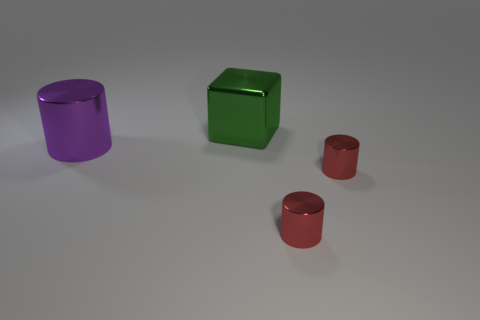Subtract all large purple metallic cylinders. How many cylinders are left? 2 Add 4 big brown rubber objects. How many objects exist? 8 Subtract all cyan spheres. How many red cylinders are left? 2 Subtract 1 blocks. How many blocks are left? 0 Subtract all red cylinders. How many cylinders are left? 1 Subtract all cubes. How many objects are left? 3 Subtract all purple blocks. Subtract all cyan spheres. How many blocks are left? 1 Subtract all yellow cylinders. Subtract all big green shiny cubes. How many objects are left? 3 Add 1 big green things. How many big green things are left? 2 Add 1 large blocks. How many large blocks exist? 2 